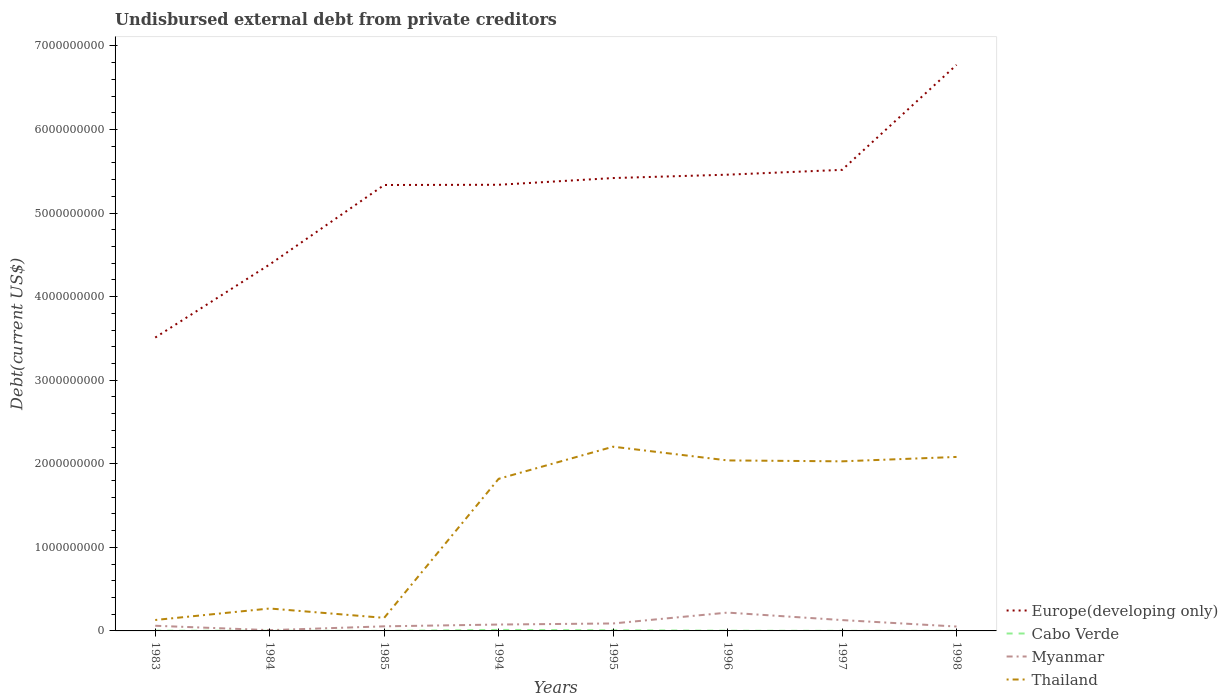Across all years, what is the maximum total debt in Cabo Verde?
Make the answer very short. 5.91e+05. In which year was the total debt in Europe(developing only) maximum?
Your answer should be very brief. 1983. What is the total total debt in Thailand in the graph?
Offer a very short reply. -1.55e+09. What is the difference between the highest and the second highest total debt in Thailand?
Provide a short and direct response. 2.07e+09. What is the difference between the highest and the lowest total debt in Thailand?
Keep it short and to the point. 5. Is the total debt in Myanmar strictly greater than the total debt in Cabo Verde over the years?
Provide a short and direct response. No. How many lines are there?
Your answer should be compact. 4. Are the values on the major ticks of Y-axis written in scientific E-notation?
Your answer should be very brief. No. Does the graph contain any zero values?
Provide a short and direct response. No. Does the graph contain grids?
Your response must be concise. No. Where does the legend appear in the graph?
Your answer should be very brief. Bottom right. How are the legend labels stacked?
Offer a terse response. Vertical. What is the title of the graph?
Offer a very short reply. Undisbursed external debt from private creditors. What is the label or title of the Y-axis?
Your response must be concise. Debt(current US$). What is the Debt(current US$) in Europe(developing only) in 1983?
Your response must be concise. 3.51e+09. What is the Debt(current US$) of Cabo Verde in 1983?
Your answer should be very brief. 3.00e+06. What is the Debt(current US$) in Myanmar in 1983?
Offer a very short reply. 6.17e+07. What is the Debt(current US$) of Thailand in 1983?
Your answer should be very brief. 1.31e+08. What is the Debt(current US$) of Europe(developing only) in 1984?
Your answer should be compact. 4.39e+09. What is the Debt(current US$) in Cabo Verde in 1984?
Offer a very short reply. 1.56e+06. What is the Debt(current US$) in Myanmar in 1984?
Provide a succinct answer. 9.16e+06. What is the Debt(current US$) of Thailand in 1984?
Provide a short and direct response. 2.68e+08. What is the Debt(current US$) of Europe(developing only) in 1985?
Provide a succinct answer. 5.34e+09. What is the Debt(current US$) of Cabo Verde in 1985?
Keep it short and to the point. 5.91e+05. What is the Debt(current US$) in Myanmar in 1985?
Your answer should be very brief. 5.49e+07. What is the Debt(current US$) in Thailand in 1985?
Your answer should be very brief. 1.56e+08. What is the Debt(current US$) in Europe(developing only) in 1994?
Provide a succinct answer. 5.34e+09. What is the Debt(current US$) of Cabo Verde in 1994?
Give a very brief answer. 1.20e+07. What is the Debt(current US$) of Myanmar in 1994?
Provide a short and direct response. 7.64e+07. What is the Debt(current US$) of Thailand in 1994?
Offer a terse response. 1.82e+09. What is the Debt(current US$) of Europe(developing only) in 1995?
Your answer should be compact. 5.42e+09. What is the Debt(current US$) in Cabo Verde in 1995?
Provide a short and direct response. 7.76e+06. What is the Debt(current US$) in Myanmar in 1995?
Give a very brief answer. 8.93e+07. What is the Debt(current US$) in Thailand in 1995?
Provide a succinct answer. 2.20e+09. What is the Debt(current US$) of Europe(developing only) in 1996?
Make the answer very short. 5.46e+09. What is the Debt(current US$) of Cabo Verde in 1996?
Your answer should be compact. 2.41e+06. What is the Debt(current US$) in Myanmar in 1996?
Your answer should be very brief. 2.19e+08. What is the Debt(current US$) of Thailand in 1996?
Provide a succinct answer. 2.04e+09. What is the Debt(current US$) in Europe(developing only) in 1997?
Ensure brevity in your answer.  5.52e+09. What is the Debt(current US$) in Cabo Verde in 1997?
Offer a terse response. 9.48e+05. What is the Debt(current US$) in Myanmar in 1997?
Ensure brevity in your answer.  1.30e+08. What is the Debt(current US$) of Thailand in 1997?
Ensure brevity in your answer.  2.03e+09. What is the Debt(current US$) in Europe(developing only) in 1998?
Provide a succinct answer. 6.77e+09. What is the Debt(current US$) in Cabo Verde in 1998?
Your response must be concise. 9.48e+05. What is the Debt(current US$) of Myanmar in 1998?
Provide a short and direct response. 5.25e+07. What is the Debt(current US$) in Thailand in 1998?
Keep it short and to the point. 2.08e+09. Across all years, what is the maximum Debt(current US$) in Europe(developing only)?
Ensure brevity in your answer.  6.77e+09. Across all years, what is the maximum Debt(current US$) of Cabo Verde?
Offer a very short reply. 1.20e+07. Across all years, what is the maximum Debt(current US$) of Myanmar?
Give a very brief answer. 2.19e+08. Across all years, what is the maximum Debt(current US$) in Thailand?
Your response must be concise. 2.20e+09. Across all years, what is the minimum Debt(current US$) of Europe(developing only)?
Your response must be concise. 3.51e+09. Across all years, what is the minimum Debt(current US$) in Cabo Verde?
Offer a terse response. 5.91e+05. Across all years, what is the minimum Debt(current US$) in Myanmar?
Provide a short and direct response. 9.16e+06. Across all years, what is the minimum Debt(current US$) of Thailand?
Provide a short and direct response. 1.31e+08. What is the total Debt(current US$) of Europe(developing only) in the graph?
Give a very brief answer. 4.17e+1. What is the total Debt(current US$) of Cabo Verde in the graph?
Make the answer very short. 2.92e+07. What is the total Debt(current US$) of Myanmar in the graph?
Your response must be concise. 6.93e+08. What is the total Debt(current US$) in Thailand in the graph?
Keep it short and to the point. 1.07e+1. What is the difference between the Debt(current US$) of Europe(developing only) in 1983 and that in 1984?
Offer a terse response. -8.75e+08. What is the difference between the Debt(current US$) in Cabo Verde in 1983 and that in 1984?
Make the answer very short. 1.44e+06. What is the difference between the Debt(current US$) of Myanmar in 1983 and that in 1984?
Your answer should be very brief. 5.25e+07. What is the difference between the Debt(current US$) in Thailand in 1983 and that in 1984?
Your answer should be very brief. -1.38e+08. What is the difference between the Debt(current US$) in Europe(developing only) in 1983 and that in 1985?
Give a very brief answer. -1.83e+09. What is the difference between the Debt(current US$) of Cabo Verde in 1983 and that in 1985?
Your response must be concise. 2.41e+06. What is the difference between the Debt(current US$) in Myanmar in 1983 and that in 1985?
Provide a succinct answer. 6.79e+06. What is the difference between the Debt(current US$) in Thailand in 1983 and that in 1985?
Ensure brevity in your answer.  -2.55e+07. What is the difference between the Debt(current US$) in Europe(developing only) in 1983 and that in 1994?
Provide a short and direct response. -1.83e+09. What is the difference between the Debt(current US$) of Cabo Verde in 1983 and that in 1994?
Give a very brief answer. -9.00e+06. What is the difference between the Debt(current US$) of Myanmar in 1983 and that in 1994?
Your response must be concise. -1.47e+07. What is the difference between the Debt(current US$) in Thailand in 1983 and that in 1994?
Your response must be concise. -1.69e+09. What is the difference between the Debt(current US$) of Europe(developing only) in 1983 and that in 1995?
Give a very brief answer. -1.91e+09. What is the difference between the Debt(current US$) of Cabo Verde in 1983 and that in 1995?
Offer a very short reply. -4.76e+06. What is the difference between the Debt(current US$) in Myanmar in 1983 and that in 1995?
Make the answer very short. -2.76e+07. What is the difference between the Debt(current US$) of Thailand in 1983 and that in 1995?
Make the answer very short. -2.07e+09. What is the difference between the Debt(current US$) in Europe(developing only) in 1983 and that in 1996?
Keep it short and to the point. -1.95e+09. What is the difference between the Debt(current US$) of Cabo Verde in 1983 and that in 1996?
Give a very brief answer. 5.92e+05. What is the difference between the Debt(current US$) of Myanmar in 1983 and that in 1996?
Your answer should be very brief. -1.58e+08. What is the difference between the Debt(current US$) in Thailand in 1983 and that in 1996?
Your answer should be compact. -1.91e+09. What is the difference between the Debt(current US$) of Europe(developing only) in 1983 and that in 1997?
Keep it short and to the point. -2.01e+09. What is the difference between the Debt(current US$) of Cabo Verde in 1983 and that in 1997?
Make the answer very short. 2.05e+06. What is the difference between the Debt(current US$) in Myanmar in 1983 and that in 1997?
Ensure brevity in your answer.  -6.81e+07. What is the difference between the Debt(current US$) in Thailand in 1983 and that in 1997?
Ensure brevity in your answer.  -1.90e+09. What is the difference between the Debt(current US$) of Europe(developing only) in 1983 and that in 1998?
Make the answer very short. -3.26e+09. What is the difference between the Debt(current US$) in Cabo Verde in 1983 and that in 1998?
Provide a short and direct response. 2.05e+06. What is the difference between the Debt(current US$) in Myanmar in 1983 and that in 1998?
Your response must be concise. 9.18e+06. What is the difference between the Debt(current US$) in Thailand in 1983 and that in 1998?
Your answer should be very brief. -1.95e+09. What is the difference between the Debt(current US$) of Europe(developing only) in 1984 and that in 1985?
Your answer should be very brief. -9.50e+08. What is the difference between the Debt(current US$) in Cabo Verde in 1984 and that in 1985?
Your response must be concise. 9.72e+05. What is the difference between the Debt(current US$) in Myanmar in 1984 and that in 1985?
Your answer should be compact. -4.57e+07. What is the difference between the Debt(current US$) in Thailand in 1984 and that in 1985?
Ensure brevity in your answer.  1.12e+08. What is the difference between the Debt(current US$) in Europe(developing only) in 1984 and that in 1994?
Your answer should be compact. -9.53e+08. What is the difference between the Debt(current US$) in Cabo Verde in 1984 and that in 1994?
Your answer should be compact. -1.04e+07. What is the difference between the Debt(current US$) in Myanmar in 1984 and that in 1994?
Make the answer very short. -6.72e+07. What is the difference between the Debt(current US$) in Thailand in 1984 and that in 1994?
Your response must be concise. -1.55e+09. What is the difference between the Debt(current US$) of Europe(developing only) in 1984 and that in 1995?
Offer a very short reply. -1.03e+09. What is the difference between the Debt(current US$) in Cabo Verde in 1984 and that in 1995?
Ensure brevity in your answer.  -6.19e+06. What is the difference between the Debt(current US$) in Myanmar in 1984 and that in 1995?
Make the answer very short. -8.01e+07. What is the difference between the Debt(current US$) of Thailand in 1984 and that in 1995?
Your answer should be very brief. -1.94e+09. What is the difference between the Debt(current US$) of Europe(developing only) in 1984 and that in 1996?
Make the answer very short. -1.07e+09. What is the difference between the Debt(current US$) of Cabo Verde in 1984 and that in 1996?
Your answer should be compact. -8.45e+05. What is the difference between the Debt(current US$) of Myanmar in 1984 and that in 1996?
Provide a short and direct response. -2.10e+08. What is the difference between the Debt(current US$) of Thailand in 1984 and that in 1996?
Give a very brief answer. -1.77e+09. What is the difference between the Debt(current US$) in Europe(developing only) in 1984 and that in 1997?
Keep it short and to the point. -1.13e+09. What is the difference between the Debt(current US$) of Cabo Verde in 1984 and that in 1997?
Ensure brevity in your answer.  6.15e+05. What is the difference between the Debt(current US$) in Myanmar in 1984 and that in 1997?
Make the answer very short. -1.21e+08. What is the difference between the Debt(current US$) of Thailand in 1984 and that in 1997?
Make the answer very short. -1.76e+09. What is the difference between the Debt(current US$) in Europe(developing only) in 1984 and that in 1998?
Provide a succinct answer. -2.39e+09. What is the difference between the Debt(current US$) in Cabo Verde in 1984 and that in 1998?
Ensure brevity in your answer.  6.15e+05. What is the difference between the Debt(current US$) in Myanmar in 1984 and that in 1998?
Keep it short and to the point. -4.33e+07. What is the difference between the Debt(current US$) in Thailand in 1984 and that in 1998?
Make the answer very short. -1.81e+09. What is the difference between the Debt(current US$) of Europe(developing only) in 1985 and that in 1994?
Your answer should be very brief. -2.66e+06. What is the difference between the Debt(current US$) of Cabo Verde in 1985 and that in 1994?
Provide a short and direct response. -1.14e+07. What is the difference between the Debt(current US$) of Myanmar in 1985 and that in 1994?
Keep it short and to the point. -2.15e+07. What is the difference between the Debt(current US$) in Thailand in 1985 and that in 1994?
Your answer should be very brief. -1.66e+09. What is the difference between the Debt(current US$) of Europe(developing only) in 1985 and that in 1995?
Your answer should be very brief. -8.31e+07. What is the difference between the Debt(current US$) in Cabo Verde in 1985 and that in 1995?
Offer a terse response. -7.16e+06. What is the difference between the Debt(current US$) in Myanmar in 1985 and that in 1995?
Give a very brief answer. -3.44e+07. What is the difference between the Debt(current US$) in Thailand in 1985 and that in 1995?
Your answer should be very brief. -2.05e+09. What is the difference between the Debt(current US$) in Europe(developing only) in 1985 and that in 1996?
Provide a short and direct response. -1.23e+08. What is the difference between the Debt(current US$) in Cabo Verde in 1985 and that in 1996?
Provide a short and direct response. -1.82e+06. What is the difference between the Debt(current US$) of Myanmar in 1985 and that in 1996?
Provide a succinct answer. -1.64e+08. What is the difference between the Debt(current US$) of Thailand in 1985 and that in 1996?
Your answer should be compact. -1.88e+09. What is the difference between the Debt(current US$) in Europe(developing only) in 1985 and that in 1997?
Your answer should be very brief. -1.81e+08. What is the difference between the Debt(current US$) in Cabo Verde in 1985 and that in 1997?
Your answer should be very brief. -3.57e+05. What is the difference between the Debt(current US$) in Myanmar in 1985 and that in 1997?
Provide a succinct answer. -7.49e+07. What is the difference between the Debt(current US$) of Thailand in 1985 and that in 1997?
Give a very brief answer. -1.87e+09. What is the difference between the Debt(current US$) of Europe(developing only) in 1985 and that in 1998?
Ensure brevity in your answer.  -1.44e+09. What is the difference between the Debt(current US$) in Cabo Verde in 1985 and that in 1998?
Make the answer very short. -3.57e+05. What is the difference between the Debt(current US$) of Myanmar in 1985 and that in 1998?
Give a very brief answer. 2.39e+06. What is the difference between the Debt(current US$) in Thailand in 1985 and that in 1998?
Offer a very short reply. -1.93e+09. What is the difference between the Debt(current US$) of Europe(developing only) in 1994 and that in 1995?
Make the answer very short. -8.05e+07. What is the difference between the Debt(current US$) in Cabo Verde in 1994 and that in 1995?
Your response must be concise. 4.24e+06. What is the difference between the Debt(current US$) in Myanmar in 1994 and that in 1995?
Offer a very short reply. -1.29e+07. What is the difference between the Debt(current US$) in Thailand in 1994 and that in 1995?
Provide a short and direct response. -3.84e+08. What is the difference between the Debt(current US$) of Europe(developing only) in 1994 and that in 1996?
Ensure brevity in your answer.  -1.21e+08. What is the difference between the Debt(current US$) in Cabo Verde in 1994 and that in 1996?
Provide a short and direct response. 9.59e+06. What is the difference between the Debt(current US$) of Myanmar in 1994 and that in 1996?
Make the answer very short. -1.43e+08. What is the difference between the Debt(current US$) in Thailand in 1994 and that in 1996?
Ensure brevity in your answer.  -2.20e+08. What is the difference between the Debt(current US$) of Europe(developing only) in 1994 and that in 1997?
Give a very brief answer. -1.78e+08. What is the difference between the Debt(current US$) of Cabo Verde in 1994 and that in 1997?
Ensure brevity in your answer.  1.11e+07. What is the difference between the Debt(current US$) of Myanmar in 1994 and that in 1997?
Give a very brief answer. -5.34e+07. What is the difference between the Debt(current US$) in Thailand in 1994 and that in 1997?
Offer a terse response. -2.09e+08. What is the difference between the Debt(current US$) in Europe(developing only) in 1994 and that in 1998?
Keep it short and to the point. -1.43e+09. What is the difference between the Debt(current US$) of Cabo Verde in 1994 and that in 1998?
Your answer should be very brief. 1.11e+07. What is the difference between the Debt(current US$) of Myanmar in 1994 and that in 1998?
Provide a succinct answer. 2.39e+07. What is the difference between the Debt(current US$) in Thailand in 1994 and that in 1998?
Your response must be concise. -2.62e+08. What is the difference between the Debt(current US$) of Europe(developing only) in 1995 and that in 1996?
Your answer should be compact. -4.04e+07. What is the difference between the Debt(current US$) in Cabo Verde in 1995 and that in 1996?
Provide a short and direct response. 5.35e+06. What is the difference between the Debt(current US$) in Myanmar in 1995 and that in 1996?
Your answer should be very brief. -1.30e+08. What is the difference between the Debt(current US$) of Thailand in 1995 and that in 1996?
Ensure brevity in your answer.  1.64e+08. What is the difference between the Debt(current US$) in Europe(developing only) in 1995 and that in 1997?
Give a very brief answer. -9.80e+07. What is the difference between the Debt(current US$) of Cabo Verde in 1995 and that in 1997?
Provide a succinct answer. 6.81e+06. What is the difference between the Debt(current US$) in Myanmar in 1995 and that in 1997?
Offer a very short reply. -4.04e+07. What is the difference between the Debt(current US$) in Thailand in 1995 and that in 1997?
Your answer should be very brief. 1.75e+08. What is the difference between the Debt(current US$) of Europe(developing only) in 1995 and that in 1998?
Your answer should be very brief. -1.35e+09. What is the difference between the Debt(current US$) of Cabo Verde in 1995 and that in 1998?
Give a very brief answer. 6.81e+06. What is the difference between the Debt(current US$) in Myanmar in 1995 and that in 1998?
Your answer should be compact. 3.68e+07. What is the difference between the Debt(current US$) in Thailand in 1995 and that in 1998?
Your answer should be compact. 1.23e+08. What is the difference between the Debt(current US$) in Europe(developing only) in 1996 and that in 1997?
Make the answer very short. -5.77e+07. What is the difference between the Debt(current US$) in Cabo Verde in 1996 and that in 1997?
Provide a succinct answer. 1.46e+06. What is the difference between the Debt(current US$) in Myanmar in 1996 and that in 1997?
Provide a short and direct response. 8.95e+07. What is the difference between the Debt(current US$) of Thailand in 1996 and that in 1997?
Keep it short and to the point. 1.09e+07. What is the difference between the Debt(current US$) of Europe(developing only) in 1996 and that in 1998?
Provide a short and direct response. -1.31e+09. What is the difference between the Debt(current US$) of Cabo Verde in 1996 and that in 1998?
Make the answer very short. 1.46e+06. What is the difference between the Debt(current US$) in Myanmar in 1996 and that in 1998?
Provide a short and direct response. 1.67e+08. What is the difference between the Debt(current US$) in Thailand in 1996 and that in 1998?
Your answer should be compact. -4.16e+07. What is the difference between the Debt(current US$) in Europe(developing only) in 1997 and that in 1998?
Your response must be concise. -1.26e+09. What is the difference between the Debt(current US$) in Myanmar in 1997 and that in 1998?
Make the answer very short. 7.72e+07. What is the difference between the Debt(current US$) in Thailand in 1997 and that in 1998?
Offer a terse response. -5.25e+07. What is the difference between the Debt(current US$) in Europe(developing only) in 1983 and the Debt(current US$) in Cabo Verde in 1984?
Offer a very short reply. 3.51e+09. What is the difference between the Debt(current US$) in Europe(developing only) in 1983 and the Debt(current US$) in Myanmar in 1984?
Make the answer very short. 3.50e+09. What is the difference between the Debt(current US$) in Europe(developing only) in 1983 and the Debt(current US$) in Thailand in 1984?
Give a very brief answer. 3.24e+09. What is the difference between the Debt(current US$) of Cabo Verde in 1983 and the Debt(current US$) of Myanmar in 1984?
Provide a short and direct response. -6.16e+06. What is the difference between the Debt(current US$) in Cabo Verde in 1983 and the Debt(current US$) in Thailand in 1984?
Give a very brief answer. -2.65e+08. What is the difference between the Debt(current US$) in Myanmar in 1983 and the Debt(current US$) in Thailand in 1984?
Offer a terse response. -2.07e+08. What is the difference between the Debt(current US$) of Europe(developing only) in 1983 and the Debt(current US$) of Cabo Verde in 1985?
Offer a terse response. 3.51e+09. What is the difference between the Debt(current US$) in Europe(developing only) in 1983 and the Debt(current US$) in Myanmar in 1985?
Your answer should be compact. 3.46e+09. What is the difference between the Debt(current US$) in Europe(developing only) in 1983 and the Debt(current US$) in Thailand in 1985?
Your answer should be very brief. 3.35e+09. What is the difference between the Debt(current US$) of Cabo Verde in 1983 and the Debt(current US$) of Myanmar in 1985?
Give a very brief answer. -5.19e+07. What is the difference between the Debt(current US$) of Cabo Verde in 1983 and the Debt(current US$) of Thailand in 1985?
Your answer should be compact. -1.53e+08. What is the difference between the Debt(current US$) of Myanmar in 1983 and the Debt(current US$) of Thailand in 1985?
Ensure brevity in your answer.  -9.46e+07. What is the difference between the Debt(current US$) in Europe(developing only) in 1983 and the Debt(current US$) in Cabo Verde in 1994?
Your answer should be compact. 3.50e+09. What is the difference between the Debt(current US$) in Europe(developing only) in 1983 and the Debt(current US$) in Myanmar in 1994?
Offer a terse response. 3.43e+09. What is the difference between the Debt(current US$) in Europe(developing only) in 1983 and the Debt(current US$) in Thailand in 1994?
Offer a terse response. 1.69e+09. What is the difference between the Debt(current US$) in Cabo Verde in 1983 and the Debt(current US$) in Myanmar in 1994?
Offer a terse response. -7.34e+07. What is the difference between the Debt(current US$) in Cabo Verde in 1983 and the Debt(current US$) in Thailand in 1994?
Ensure brevity in your answer.  -1.82e+09. What is the difference between the Debt(current US$) in Myanmar in 1983 and the Debt(current US$) in Thailand in 1994?
Your answer should be compact. -1.76e+09. What is the difference between the Debt(current US$) in Europe(developing only) in 1983 and the Debt(current US$) in Cabo Verde in 1995?
Provide a short and direct response. 3.50e+09. What is the difference between the Debt(current US$) of Europe(developing only) in 1983 and the Debt(current US$) of Myanmar in 1995?
Your answer should be compact. 3.42e+09. What is the difference between the Debt(current US$) of Europe(developing only) in 1983 and the Debt(current US$) of Thailand in 1995?
Your response must be concise. 1.31e+09. What is the difference between the Debt(current US$) in Cabo Verde in 1983 and the Debt(current US$) in Myanmar in 1995?
Keep it short and to the point. -8.63e+07. What is the difference between the Debt(current US$) in Cabo Verde in 1983 and the Debt(current US$) in Thailand in 1995?
Provide a succinct answer. -2.20e+09. What is the difference between the Debt(current US$) in Myanmar in 1983 and the Debt(current US$) in Thailand in 1995?
Offer a very short reply. -2.14e+09. What is the difference between the Debt(current US$) of Europe(developing only) in 1983 and the Debt(current US$) of Cabo Verde in 1996?
Give a very brief answer. 3.51e+09. What is the difference between the Debt(current US$) in Europe(developing only) in 1983 and the Debt(current US$) in Myanmar in 1996?
Give a very brief answer. 3.29e+09. What is the difference between the Debt(current US$) in Europe(developing only) in 1983 and the Debt(current US$) in Thailand in 1996?
Offer a very short reply. 1.47e+09. What is the difference between the Debt(current US$) of Cabo Verde in 1983 and the Debt(current US$) of Myanmar in 1996?
Provide a short and direct response. -2.16e+08. What is the difference between the Debt(current US$) in Cabo Verde in 1983 and the Debt(current US$) in Thailand in 1996?
Give a very brief answer. -2.04e+09. What is the difference between the Debt(current US$) of Myanmar in 1983 and the Debt(current US$) of Thailand in 1996?
Provide a short and direct response. -1.98e+09. What is the difference between the Debt(current US$) in Europe(developing only) in 1983 and the Debt(current US$) in Cabo Verde in 1997?
Make the answer very short. 3.51e+09. What is the difference between the Debt(current US$) in Europe(developing only) in 1983 and the Debt(current US$) in Myanmar in 1997?
Your response must be concise. 3.38e+09. What is the difference between the Debt(current US$) of Europe(developing only) in 1983 and the Debt(current US$) of Thailand in 1997?
Keep it short and to the point. 1.48e+09. What is the difference between the Debt(current US$) in Cabo Verde in 1983 and the Debt(current US$) in Myanmar in 1997?
Your response must be concise. -1.27e+08. What is the difference between the Debt(current US$) of Cabo Verde in 1983 and the Debt(current US$) of Thailand in 1997?
Your response must be concise. -2.03e+09. What is the difference between the Debt(current US$) of Myanmar in 1983 and the Debt(current US$) of Thailand in 1997?
Provide a succinct answer. -1.97e+09. What is the difference between the Debt(current US$) of Europe(developing only) in 1983 and the Debt(current US$) of Cabo Verde in 1998?
Give a very brief answer. 3.51e+09. What is the difference between the Debt(current US$) of Europe(developing only) in 1983 and the Debt(current US$) of Myanmar in 1998?
Provide a succinct answer. 3.46e+09. What is the difference between the Debt(current US$) of Europe(developing only) in 1983 and the Debt(current US$) of Thailand in 1998?
Provide a succinct answer. 1.43e+09. What is the difference between the Debt(current US$) of Cabo Verde in 1983 and the Debt(current US$) of Myanmar in 1998?
Your response must be concise. -4.95e+07. What is the difference between the Debt(current US$) in Cabo Verde in 1983 and the Debt(current US$) in Thailand in 1998?
Offer a very short reply. -2.08e+09. What is the difference between the Debt(current US$) of Myanmar in 1983 and the Debt(current US$) of Thailand in 1998?
Your response must be concise. -2.02e+09. What is the difference between the Debt(current US$) of Europe(developing only) in 1984 and the Debt(current US$) of Cabo Verde in 1985?
Provide a succinct answer. 4.38e+09. What is the difference between the Debt(current US$) in Europe(developing only) in 1984 and the Debt(current US$) in Myanmar in 1985?
Provide a succinct answer. 4.33e+09. What is the difference between the Debt(current US$) of Europe(developing only) in 1984 and the Debt(current US$) of Thailand in 1985?
Offer a terse response. 4.23e+09. What is the difference between the Debt(current US$) of Cabo Verde in 1984 and the Debt(current US$) of Myanmar in 1985?
Provide a short and direct response. -5.33e+07. What is the difference between the Debt(current US$) of Cabo Verde in 1984 and the Debt(current US$) of Thailand in 1985?
Provide a succinct answer. -1.55e+08. What is the difference between the Debt(current US$) in Myanmar in 1984 and the Debt(current US$) in Thailand in 1985?
Offer a terse response. -1.47e+08. What is the difference between the Debt(current US$) of Europe(developing only) in 1984 and the Debt(current US$) of Cabo Verde in 1994?
Offer a terse response. 4.37e+09. What is the difference between the Debt(current US$) of Europe(developing only) in 1984 and the Debt(current US$) of Myanmar in 1994?
Give a very brief answer. 4.31e+09. What is the difference between the Debt(current US$) in Europe(developing only) in 1984 and the Debt(current US$) in Thailand in 1994?
Keep it short and to the point. 2.57e+09. What is the difference between the Debt(current US$) of Cabo Verde in 1984 and the Debt(current US$) of Myanmar in 1994?
Give a very brief answer. -7.48e+07. What is the difference between the Debt(current US$) in Cabo Verde in 1984 and the Debt(current US$) in Thailand in 1994?
Make the answer very short. -1.82e+09. What is the difference between the Debt(current US$) of Myanmar in 1984 and the Debt(current US$) of Thailand in 1994?
Your answer should be very brief. -1.81e+09. What is the difference between the Debt(current US$) in Europe(developing only) in 1984 and the Debt(current US$) in Cabo Verde in 1995?
Your answer should be compact. 4.38e+09. What is the difference between the Debt(current US$) of Europe(developing only) in 1984 and the Debt(current US$) of Myanmar in 1995?
Offer a terse response. 4.30e+09. What is the difference between the Debt(current US$) in Europe(developing only) in 1984 and the Debt(current US$) in Thailand in 1995?
Ensure brevity in your answer.  2.18e+09. What is the difference between the Debt(current US$) of Cabo Verde in 1984 and the Debt(current US$) of Myanmar in 1995?
Provide a short and direct response. -8.77e+07. What is the difference between the Debt(current US$) in Cabo Verde in 1984 and the Debt(current US$) in Thailand in 1995?
Provide a succinct answer. -2.20e+09. What is the difference between the Debt(current US$) of Myanmar in 1984 and the Debt(current US$) of Thailand in 1995?
Your answer should be very brief. -2.20e+09. What is the difference between the Debt(current US$) in Europe(developing only) in 1984 and the Debt(current US$) in Cabo Verde in 1996?
Your answer should be very brief. 4.38e+09. What is the difference between the Debt(current US$) in Europe(developing only) in 1984 and the Debt(current US$) in Myanmar in 1996?
Offer a terse response. 4.17e+09. What is the difference between the Debt(current US$) in Europe(developing only) in 1984 and the Debt(current US$) in Thailand in 1996?
Your answer should be compact. 2.35e+09. What is the difference between the Debt(current US$) in Cabo Verde in 1984 and the Debt(current US$) in Myanmar in 1996?
Offer a terse response. -2.18e+08. What is the difference between the Debt(current US$) in Cabo Verde in 1984 and the Debt(current US$) in Thailand in 1996?
Give a very brief answer. -2.04e+09. What is the difference between the Debt(current US$) of Myanmar in 1984 and the Debt(current US$) of Thailand in 1996?
Make the answer very short. -2.03e+09. What is the difference between the Debt(current US$) in Europe(developing only) in 1984 and the Debt(current US$) in Cabo Verde in 1997?
Keep it short and to the point. 4.38e+09. What is the difference between the Debt(current US$) in Europe(developing only) in 1984 and the Debt(current US$) in Myanmar in 1997?
Keep it short and to the point. 4.26e+09. What is the difference between the Debt(current US$) of Europe(developing only) in 1984 and the Debt(current US$) of Thailand in 1997?
Your response must be concise. 2.36e+09. What is the difference between the Debt(current US$) in Cabo Verde in 1984 and the Debt(current US$) in Myanmar in 1997?
Offer a very short reply. -1.28e+08. What is the difference between the Debt(current US$) in Cabo Verde in 1984 and the Debt(current US$) in Thailand in 1997?
Ensure brevity in your answer.  -2.03e+09. What is the difference between the Debt(current US$) in Myanmar in 1984 and the Debt(current US$) in Thailand in 1997?
Your response must be concise. -2.02e+09. What is the difference between the Debt(current US$) of Europe(developing only) in 1984 and the Debt(current US$) of Cabo Verde in 1998?
Offer a terse response. 4.38e+09. What is the difference between the Debt(current US$) in Europe(developing only) in 1984 and the Debt(current US$) in Myanmar in 1998?
Provide a short and direct response. 4.33e+09. What is the difference between the Debt(current US$) of Europe(developing only) in 1984 and the Debt(current US$) of Thailand in 1998?
Provide a succinct answer. 2.30e+09. What is the difference between the Debt(current US$) of Cabo Verde in 1984 and the Debt(current US$) of Myanmar in 1998?
Offer a terse response. -5.09e+07. What is the difference between the Debt(current US$) of Cabo Verde in 1984 and the Debt(current US$) of Thailand in 1998?
Your answer should be very brief. -2.08e+09. What is the difference between the Debt(current US$) in Myanmar in 1984 and the Debt(current US$) in Thailand in 1998?
Offer a very short reply. -2.07e+09. What is the difference between the Debt(current US$) in Europe(developing only) in 1985 and the Debt(current US$) in Cabo Verde in 1994?
Provide a short and direct response. 5.32e+09. What is the difference between the Debt(current US$) in Europe(developing only) in 1985 and the Debt(current US$) in Myanmar in 1994?
Ensure brevity in your answer.  5.26e+09. What is the difference between the Debt(current US$) of Europe(developing only) in 1985 and the Debt(current US$) of Thailand in 1994?
Your response must be concise. 3.52e+09. What is the difference between the Debt(current US$) of Cabo Verde in 1985 and the Debt(current US$) of Myanmar in 1994?
Your answer should be very brief. -7.58e+07. What is the difference between the Debt(current US$) in Cabo Verde in 1985 and the Debt(current US$) in Thailand in 1994?
Provide a succinct answer. -1.82e+09. What is the difference between the Debt(current US$) of Myanmar in 1985 and the Debt(current US$) of Thailand in 1994?
Give a very brief answer. -1.77e+09. What is the difference between the Debt(current US$) in Europe(developing only) in 1985 and the Debt(current US$) in Cabo Verde in 1995?
Ensure brevity in your answer.  5.33e+09. What is the difference between the Debt(current US$) in Europe(developing only) in 1985 and the Debt(current US$) in Myanmar in 1995?
Your response must be concise. 5.25e+09. What is the difference between the Debt(current US$) in Europe(developing only) in 1985 and the Debt(current US$) in Thailand in 1995?
Your response must be concise. 3.13e+09. What is the difference between the Debt(current US$) in Cabo Verde in 1985 and the Debt(current US$) in Myanmar in 1995?
Keep it short and to the point. -8.87e+07. What is the difference between the Debt(current US$) in Cabo Verde in 1985 and the Debt(current US$) in Thailand in 1995?
Keep it short and to the point. -2.20e+09. What is the difference between the Debt(current US$) of Myanmar in 1985 and the Debt(current US$) of Thailand in 1995?
Give a very brief answer. -2.15e+09. What is the difference between the Debt(current US$) in Europe(developing only) in 1985 and the Debt(current US$) in Cabo Verde in 1996?
Your answer should be very brief. 5.33e+09. What is the difference between the Debt(current US$) in Europe(developing only) in 1985 and the Debt(current US$) in Myanmar in 1996?
Keep it short and to the point. 5.12e+09. What is the difference between the Debt(current US$) in Europe(developing only) in 1985 and the Debt(current US$) in Thailand in 1996?
Keep it short and to the point. 3.30e+09. What is the difference between the Debt(current US$) of Cabo Verde in 1985 and the Debt(current US$) of Myanmar in 1996?
Offer a terse response. -2.19e+08. What is the difference between the Debt(current US$) of Cabo Verde in 1985 and the Debt(current US$) of Thailand in 1996?
Your answer should be very brief. -2.04e+09. What is the difference between the Debt(current US$) of Myanmar in 1985 and the Debt(current US$) of Thailand in 1996?
Keep it short and to the point. -1.99e+09. What is the difference between the Debt(current US$) of Europe(developing only) in 1985 and the Debt(current US$) of Cabo Verde in 1997?
Make the answer very short. 5.33e+09. What is the difference between the Debt(current US$) of Europe(developing only) in 1985 and the Debt(current US$) of Myanmar in 1997?
Provide a succinct answer. 5.21e+09. What is the difference between the Debt(current US$) in Europe(developing only) in 1985 and the Debt(current US$) in Thailand in 1997?
Keep it short and to the point. 3.31e+09. What is the difference between the Debt(current US$) in Cabo Verde in 1985 and the Debt(current US$) in Myanmar in 1997?
Provide a short and direct response. -1.29e+08. What is the difference between the Debt(current US$) in Cabo Verde in 1985 and the Debt(current US$) in Thailand in 1997?
Provide a succinct answer. -2.03e+09. What is the difference between the Debt(current US$) of Myanmar in 1985 and the Debt(current US$) of Thailand in 1997?
Your response must be concise. -1.97e+09. What is the difference between the Debt(current US$) in Europe(developing only) in 1985 and the Debt(current US$) in Cabo Verde in 1998?
Provide a succinct answer. 5.33e+09. What is the difference between the Debt(current US$) in Europe(developing only) in 1985 and the Debt(current US$) in Myanmar in 1998?
Give a very brief answer. 5.28e+09. What is the difference between the Debt(current US$) in Europe(developing only) in 1985 and the Debt(current US$) in Thailand in 1998?
Keep it short and to the point. 3.25e+09. What is the difference between the Debt(current US$) of Cabo Verde in 1985 and the Debt(current US$) of Myanmar in 1998?
Your response must be concise. -5.19e+07. What is the difference between the Debt(current US$) of Cabo Verde in 1985 and the Debt(current US$) of Thailand in 1998?
Your answer should be very brief. -2.08e+09. What is the difference between the Debt(current US$) in Myanmar in 1985 and the Debt(current US$) in Thailand in 1998?
Ensure brevity in your answer.  -2.03e+09. What is the difference between the Debt(current US$) in Europe(developing only) in 1994 and the Debt(current US$) in Cabo Verde in 1995?
Ensure brevity in your answer.  5.33e+09. What is the difference between the Debt(current US$) of Europe(developing only) in 1994 and the Debt(current US$) of Myanmar in 1995?
Provide a short and direct response. 5.25e+09. What is the difference between the Debt(current US$) of Europe(developing only) in 1994 and the Debt(current US$) of Thailand in 1995?
Give a very brief answer. 3.13e+09. What is the difference between the Debt(current US$) of Cabo Verde in 1994 and the Debt(current US$) of Myanmar in 1995?
Keep it short and to the point. -7.73e+07. What is the difference between the Debt(current US$) in Cabo Verde in 1994 and the Debt(current US$) in Thailand in 1995?
Give a very brief answer. -2.19e+09. What is the difference between the Debt(current US$) of Myanmar in 1994 and the Debt(current US$) of Thailand in 1995?
Keep it short and to the point. -2.13e+09. What is the difference between the Debt(current US$) in Europe(developing only) in 1994 and the Debt(current US$) in Cabo Verde in 1996?
Offer a terse response. 5.34e+09. What is the difference between the Debt(current US$) of Europe(developing only) in 1994 and the Debt(current US$) of Myanmar in 1996?
Provide a short and direct response. 5.12e+09. What is the difference between the Debt(current US$) in Europe(developing only) in 1994 and the Debt(current US$) in Thailand in 1996?
Provide a succinct answer. 3.30e+09. What is the difference between the Debt(current US$) in Cabo Verde in 1994 and the Debt(current US$) in Myanmar in 1996?
Your answer should be very brief. -2.07e+08. What is the difference between the Debt(current US$) in Cabo Verde in 1994 and the Debt(current US$) in Thailand in 1996?
Ensure brevity in your answer.  -2.03e+09. What is the difference between the Debt(current US$) in Myanmar in 1994 and the Debt(current US$) in Thailand in 1996?
Ensure brevity in your answer.  -1.96e+09. What is the difference between the Debt(current US$) in Europe(developing only) in 1994 and the Debt(current US$) in Cabo Verde in 1997?
Offer a very short reply. 5.34e+09. What is the difference between the Debt(current US$) in Europe(developing only) in 1994 and the Debt(current US$) in Myanmar in 1997?
Give a very brief answer. 5.21e+09. What is the difference between the Debt(current US$) of Europe(developing only) in 1994 and the Debt(current US$) of Thailand in 1997?
Your answer should be very brief. 3.31e+09. What is the difference between the Debt(current US$) of Cabo Verde in 1994 and the Debt(current US$) of Myanmar in 1997?
Offer a very short reply. -1.18e+08. What is the difference between the Debt(current US$) of Cabo Verde in 1994 and the Debt(current US$) of Thailand in 1997?
Keep it short and to the point. -2.02e+09. What is the difference between the Debt(current US$) of Myanmar in 1994 and the Debt(current US$) of Thailand in 1997?
Offer a terse response. -1.95e+09. What is the difference between the Debt(current US$) in Europe(developing only) in 1994 and the Debt(current US$) in Cabo Verde in 1998?
Offer a terse response. 5.34e+09. What is the difference between the Debt(current US$) of Europe(developing only) in 1994 and the Debt(current US$) of Myanmar in 1998?
Ensure brevity in your answer.  5.29e+09. What is the difference between the Debt(current US$) of Europe(developing only) in 1994 and the Debt(current US$) of Thailand in 1998?
Your answer should be very brief. 3.26e+09. What is the difference between the Debt(current US$) in Cabo Verde in 1994 and the Debt(current US$) in Myanmar in 1998?
Your answer should be very brief. -4.05e+07. What is the difference between the Debt(current US$) of Cabo Verde in 1994 and the Debt(current US$) of Thailand in 1998?
Your response must be concise. -2.07e+09. What is the difference between the Debt(current US$) of Myanmar in 1994 and the Debt(current US$) of Thailand in 1998?
Offer a very short reply. -2.01e+09. What is the difference between the Debt(current US$) in Europe(developing only) in 1995 and the Debt(current US$) in Cabo Verde in 1996?
Offer a very short reply. 5.42e+09. What is the difference between the Debt(current US$) in Europe(developing only) in 1995 and the Debt(current US$) in Myanmar in 1996?
Offer a terse response. 5.20e+09. What is the difference between the Debt(current US$) in Europe(developing only) in 1995 and the Debt(current US$) in Thailand in 1996?
Make the answer very short. 3.38e+09. What is the difference between the Debt(current US$) of Cabo Verde in 1995 and the Debt(current US$) of Myanmar in 1996?
Make the answer very short. -2.12e+08. What is the difference between the Debt(current US$) in Cabo Verde in 1995 and the Debt(current US$) in Thailand in 1996?
Ensure brevity in your answer.  -2.03e+09. What is the difference between the Debt(current US$) in Myanmar in 1995 and the Debt(current US$) in Thailand in 1996?
Make the answer very short. -1.95e+09. What is the difference between the Debt(current US$) in Europe(developing only) in 1995 and the Debt(current US$) in Cabo Verde in 1997?
Offer a very short reply. 5.42e+09. What is the difference between the Debt(current US$) of Europe(developing only) in 1995 and the Debt(current US$) of Myanmar in 1997?
Your response must be concise. 5.29e+09. What is the difference between the Debt(current US$) of Europe(developing only) in 1995 and the Debt(current US$) of Thailand in 1997?
Ensure brevity in your answer.  3.39e+09. What is the difference between the Debt(current US$) in Cabo Verde in 1995 and the Debt(current US$) in Myanmar in 1997?
Keep it short and to the point. -1.22e+08. What is the difference between the Debt(current US$) of Cabo Verde in 1995 and the Debt(current US$) of Thailand in 1997?
Give a very brief answer. -2.02e+09. What is the difference between the Debt(current US$) in Myanmar in 1995 and the Debt(current US$) in Thailand in 1997?
Your response must be concise. -1.94e+09. What is the difference between the Debt(current US$) in Europe(developing only) in 1995 and the Debt(current US$) in Cabo Verde in 1998?
Offer a terse response. 5.42e+09. What is the difference between the Debt(current US$) of Europe(developing only) in 1995 and the Debt(current US$) of Myanmar in 1998?
Your answer should be compact. 5.37e+09. What is the difference between the Debt(current US$) in Europe(developing only) in 1995 and the Debt(current US$) in Thailand in 1998?
Offer a terse response. 3.34e+09. What is the difference between the Debt(current US$) in Cabo Verde in 1995 and the Debt(current US$) in Myanmar in 1998?
Provide a succinct answer. -4.47e+07. What is the difference between the Debt(current US$) in Cabo Verde in 1995 and the Debt(current US$) in Thailand in 1998?
Provide a short and direct response. -2.07e+09. What is the difference between the Debt(current US$) of Myanmar in 1995 and the Debt(current US$) of Thailand in 1998?
Give a very brief answer. -1.99e+09. What is the difference between the Debt(current US$) in Europe(developing only) in 1996 and the Debt(current US$) in Cabo Verde in 1997?
Your answer should be very brief. 5.46e+09. What is the difference between the Debt(current US$) of Europe(developing only) in 1996 and the Debt(current US$) of Myanmar in 1997?
Your answer should be compact. 5.33e+09. What is the difference between the Debt(current US$) of Europe(developing only) in 1996 and the Debt(current US$) of Thailand in 1997?
Make the answer very short. 3.43e+09. What is the difference between the Debt(current US$) of Cabo Verde in 1996 and the Debt(current US$) of Myanmar in 1997?
Offer a terse response. -1.27e+08. What is the difference between the Debt(current US$) in Cabo Verde in 1996 and the Debt(current US$) in Thailand in 1997?
Ensure brevity in your answer.  -2.03e+09. What is the difference between the Debt(current US$) in Myanmar in 1996 and the Debt(current US$) in Thailand in 1997?
Your answer should be compact. -1.81e+09. What is the difference between the Debt(current US$) in Europe(developing only) in 1996 and the Debt(current US$) in Cabo Verde in 1998?
Make the answer very short. 5.46e+09. What is the difference between the Debt(current US$) of Europe(developing only) in 1996 and the Debt(current US$) of Myanmar in 1998?
Your response must be concise. 5.41e+09. What is the difference between the Debt(current US$) in Europe(developing only) in 1996 and the Debt(current US$) in Thailand in 1998?
Your answer should be compact. 3.38e+09. What is the difference between the Debt(current US$) in Cabo Verde in 1996 and the Debt(current US$) in Myanmar in 1998?
Your answer should be very brief. -5.01e+07. What is the difference between the Debt(current US$) in Cabo Verde in 1996 and the Debt(current US$) in Thailand in 1998?
Ensure brevity in your answer.  -2.08e+09. What is the difference between the Debt(current US$) of Myanmar in 1996 and the Debt(current US$) of Thailand in 1998?
Keep it short and to the point. -1.86e+09. What is the difference between the Debt(current US$) of Europe(developing only) in 1997 and the Debt(current US$) of Cabo Verde in 1998?
Give a very brief answer. 5.52e+09. What is the difference between the Debt(current US$) in Europe(developing only) in 1997 and the Debt(current US$) in Myanmar in 1998?
Make the answer very short. 5.46e+09. What is the difference between the Debt(current US$) of Europe(developing only) in 1997 and the Debt(current US$) of Thailand in 1998?
Your response must be concise. 3.44e+09. What is the difference between the Debt(current US$) in Cabo Verde in 1997 and the Debt(current US$) in Myanmar in 1998?
Provide a succinct answer. -5.15e+07. What is the difference between the Debt(current US$) in Cabo Verde in 1997 and the Debt(current US$) in Thailand in 1998?
Offer a very short reply. -2.08e+09. What is the difference between the Debt(current US$) of Myanmar in 1997 and the Debt(current US$) of Thailand in 1998?
Ensure brevity in your answer.  -1.95e+09. What is the average Debt(current US$) of Europe(developing only) per year?
Provide a short and direct response. 5.22e+09. What is the average Debt(current US$) in Cabo Verde per year?
Your answer should be very brief. 3.65e+06. What is the average Debt(current US$) of Myanmar per year?
Your answer should be very brief. 8.66e+07. What is the average Debt(current US$) of Thailand per year?
Ensure brevity in your answer.  1.34e+09. In the year 1983, what is the difference between the Debt(current US$) of Europe(developing only) and Debt(current US$) of Cabo Verde?
Provide a short and direct response. 3.51e+09. In the year 1983, what is the difference between the Debt(current US$) of Europe(developing only) and Debt(current US$) of Myanmar?
Provide a short and direct response. 3.45e+09. In the year 1983, what is the difference between the Debt(current US$) in Europe(developing only) and Debt(current US$) in Thailand?
Keep it short and to the point. 3.38e+09. In the year 1983, what is the difference between the Debt(current US$) in Cabo Verde and Debt(current US$) in Myanmar?
Your response must be concise. -5.87e+07. In the year 1983, what is the difference between the Debt(current US$) of Cabo Verde and Debt(current US$) of Thailand?
Give a very brief answer. -1.28e+08. In the year 1983, what is the difference between the Debt(current US$) of Myanmar and Debt(current US$) of Thailand?
Offer a terse response. -6.91e+07. In the year 1984, what is the difference between the Debt(current US$) in Europe(developing only) and Debt(current US$) in Cabo Verde?
Offer a terse response. 4.38e+09. In the year 1984, what is the difference between the Debt(current US$) in Europe(developing only) and Debt(current US$) in Myanmar?
Your response must be concise. 4.38e+09. In the year 1984, what is the difference between the Debt(current US$) in Europe(developing only) and Debt(current US$) in Thailand?
Offer a very short reply. 4.12e+09. In the year 1984, what is the difference between the Debt(current US$) of Cabo Verde and Debt(current US$) of Myanmar?
Your response must be concise. -7.60e+06. In the year 1984, what is the difference between the Debt(current US$) of Cabo Verde and Debt(current US$) of Thailand?
Your answer should be compact. -2.67e+08. In the year 1984, what is the difference between the Debt(current US$) of Myanmar and Debt(current US$) of Thailand?
Offer a very short reply. -2.59e+08. In the year 1985, what is the difference between the Debt(current US$) of Europe(developing only) and Debt(current US$) of Cabo Verde?
Provide a succinct answer. 5.34e+09. In the year 1985, what is the difference between the Debt(current US$) of Europe(developing only) and Debt(current US$) of Myanmar?
Keep it short and to the point. 5.28e+09. In the year 1985, what is the difference between the Debt(current US$) in Europe(developing only) and Debt(current US$) in Thailand?
Provide a succinct answer. 5.18e+09. In the year 1985, what is the difference between the Debt(current US$) in Cabo Verde and Debt(current US$) in Myanmar?
Provide a short and direct response. -5.43e+07. In the year 1985, what is the difference between the Debt(current US$) in Cabo Verde and Debt(current US$) in Thailand?
Your answer should be very brief. -1.56e+08. In the year 1985, what is the difference between the Debt(current US$) in Myanmar and Debt(current US$) in Thailand?
Offer a very short reply. -1.01e+08. In the year 1994, what is the difference between the Debt(current US$) in Europe(developing only) and Debt(current US$) in Cabo Verde?
Your response must be concise. 5.33e+09. In the year 1994, what is the difference between the Debt(current US$) of Europe(developing only) and Debt(current US$) of Myanmar?
Provide a short and direct response. 5.26e+09. In the year 1994, what is the difference between the Debt(current US$) in Europe(developing only) and Debt(current US$) in Thailand?
Keep it short and to the point. 3.52e+09. In the year 1994, what is the difference between the Debt(current US$) in Cabo Verde and Debt(current US$) in Myanmar?
Ensure brevity in your answer.  -6.44e+07. In the year 1994, what is the difference between the Debt(current US$) in Cabo Verde and Debt(current US$) in Thailand?
Provide a short and direct response. -1.81e+09. In the year 1994, what is the difference between the Debt(current US$) of Myanmar and Debt(current US$) of Thailand?
Keep it short and to the point. -1.74e+09. In the year 1995, what is the difference between the Debt(current US$) of Europe(developing only) and Debt(current US$) of Cabo Verde?
Offer a very short reply. 5.41e+09. In the year 1995, what is the difference between the Debt(current US$) in Europe(developing only) and Debt(current US$) in Myanmar?
Your answer should be very brief. 5.33e+09. In the year 1995, what is the difference between the Debt(current US$) in Europe(developing only) and Debt(current US$) in Thailand?
Make the answer very short. 3.21e+09. In the year 1995, what is the difference between the Debt(current US$) of Cabo Verde and Debt(current US$) of Myanmar?
Give a very brief answer. -8.15e+07. In the year 1995, what is the difference between the Debt(current US$) of Cabo Verde and Debt(current US$) of Thailand?
Your answer should be compact. -2.20e+09. In the year 1995, what is the difference between the Debt(current US$) of Myanmar and Debt(current US$) of Thailand?
Make the answer very short. -2.11e+09. In the year 1996, what is the difference between the Debt(current US$) in Europe(developing only) and Debt(current US$) in Cabo Verde?
Offer a terse response. 5.46e+09. In the year 1996, what is the difference between the Debt(current US$) in Europe(developing only) and Debt(current US$) in Myanmar?
Give a very brief answer. 5.24e+09. In the year 1996, what is the difference between the Debt(current US$) of Europe(developing only) and Debt(current US$) of Thailand?
Provide a succinct answer. 3.42e+09. In the year 1996, what is the difference between the Debt(current US$) of Cabo Verde and Debt(current US$) of Myanmar?
Offer a very short reply. -2.17e+08. In the year 1996, what is the difference between the Debt(current US$) in Cabo Verde and Debt(current US$) in Thailand?
Your response must be concise. -2.04e+09. In the year 1996, what is the difference between the Debt(current US$) in Myanmar and Debt(current US$) in Thailand?
Provide a succinct answer. -1.82e+09. In the year 1997, what is the difference between the Debt(current US$) in Europe(developing only) and Debt(current US$) in Cabo Verde?
Your answer should be very brief. 5.52e+09. In the year 1997, what is the difference between the Debt(current US$) of Europe(developing only) and Debt(current US$) of Myanmar?
Your answer should be very brief. 5.39e+09. In the year 1997, what is the difference between the Debt(current US$) in Europe(developing only) and Debt(current US$) in Thailand?
Give a very brief answer. 3.49e+09. In the year 1997, what is the difference between the Debt(current US$) of Cabo Verde and Debt(current US$) of Myanmar?
Offer a very short reply. -1.29e+08. In the year 1997, what is the difference between the Debt(current US$) in Cabo Verde and Debt(current US$) in Thailand?
Offer a terse response. -2.03e+09. In the year 1997, what is the difference between the Debt(current US$) of Myanmar and Debt(current US$) of Thailand?
Provide a succinct answer. -1.90e+09. In the year 1998, what is the difference between the Debt(current US$) in Europe(developing only) and Debt(current US$) in Cabo Verde?
Your response must be concise. 6.77e+09. In the year 1998, what is the difference between the Debt(current US$) of Europe(developing only) and Debt(current US$) of Myanmar?
Ensure brevity in your answer.  6.72e+09. In the year 1998, what is the difference between the Debt(current US$) in Europe(developing only) and Debt(current US$) in Thailand?
Keep it short and to the point. 4.69e+09. In the year 1998, what is the difference between the Debt(current US$) of Cabo Verde and Debt(current US$) of Myanmar?
Offer a terse response. -5.15e+07. In the year 1998, what is the difference between the Debt(current US$) of Cabo Verde and Debt(current US$) of Thailand?
Make the answer very short. -2.08e+09. In the year 1998, what is the difference between the Debt(current US$) of Myanmar and Debt(current US$) of Thailand?
Offer a very short reply. -2.03e+09. What is the ratio of the Debt(current US$) in Europe(developing only) in 1983 to that in 1984?
Your answer should be compact. 0.8. What is the ratio of the Debt(current US$) of Cabo Verde in 1983 to that in 1984?
Keep it short and to the point. 1.92. What is the ratio of the Debt(current US$) of Myanmar in 1983 to that in 1984?
Your answer should be very brief. 6.73. What is the ratio of the Debt(current US$) in Thailand in 1983 to that in 1984?
Provide a succinct answer. 0.49. What is the ratio of the Debt(current US$) of Europe(developing only) in 1983 to that in 1985?
Your response must be concise. 0.66. What is the ratio of the Debt(current US$) in Cabo Verde in 1983 to that in 1985?
Provide a succinct answer. 5.08. What is the ratio of the Debt(current US$) of Myanmar in 1983 to that in 1985?
Your answer should be very brief. 1.12. What is the ratio of the Debt(current US$) of Thailand in 1983 to that in 1985?
Provide a succinct answer. 0.84. What is the ratio of the Debt(current US$) of Europe(developing only) in 1983 to that in 1994?
Make the answer very short. 0.66. What is the ratio of the Debt(current US$) of Cabo Verde in 1983 to that in 1994?
Offer a terse response. 0.25. What is the ratio of the Debt(current US$) in Myanmar in 1983 to that in 1994?
Offer a terse response. 0.81. What is the ratio of the Debt(current US$) in Thailand in 1983 to that in 1994?
Offer a terse response. 0.07. What is the ratio of the Debt(current US$) of Europe(developing only) in 1983 to that in 1995?
Your answer should be very brief. 0.65. What is the ratio of the Debt(current US$) in Cabo Verde in 1983 to that in 1995?
Provide a succinct answer. 0.39. What is the ratio of the Debt(current US$) in Myanmar in 1983 to that in 1995?
Your response must be concise. 0.69. What is the ratio of the Debt(current US$) of Thailand in 1983 to that in 1995?
Offer a very short reply. 0.06. What is the ratio of the Debt(current US$) of Europe(developing only) in 1983 to that in 1996?
Give a very brief answer. 0.64. What is the ratio of the Debt(current US$) in Cabo Verde in 1983 to that in 1996?
Offer a very short reply. 1.25. What is the ratio of the Debt(current US$) of Myanmar in 1983 to that in 1996?
Provide a short and direct response. 0.28. What is the ratio of the Debt(current US$) of Thailand in 1983 to that in 1996?
Ensure brevity in your answer.  0.06. What is the ratio of the Debt(current US$) of Europe(developing only) in 1983 to that in 1997?
Your answer should be very brief. 0.64. What is the ratio of the Debt(current US$) in Cabo Verde in 1983 to that in 1997?
Your response must be concise. 3.16. What is the ratio of the Debt(current US$) of Myanmar in 1983 to that in 1997?
Your answer should be compact. 0.48. What is the ratio of the Debt(current US$) in Thailand in 1983 to that in 1997?
Offer a very short reply. 0.06. What is the ratio of the Debt(current US$) in Europe(developing only) in 1983 to that in 1998?
Offer a terse response. 0.52. What is the ratio of the Debt(current US$) in Cabo Verde in 1983 to that in 1998?
Your response must be concise. 3.16. What is the ratio of the Debt(current US$) in Myanmar in 1983 to that in 1998?
Offer a terse response. 1.17. What is the ratio of the Debt(current US$) in Thailand in 1983 to that in 1998?
Your response must be concise. 0.06. What is the ratio of the Debt(current US$) in Europe(developing only) in 1984 to that in 1985?
Your response must be concise. 0.82. What is the ratio of the Debt(current US$) of Cabo Verde in 1984 to that in 1985?
Keep it short and to the point. 2.64. What is the ratio of the Debt(current US$) in Myanmar in 1984 to that in 1985?
Make the answer very short. 0.17. What is the ratio of the Debt(current US$) of Thailand in 1984 to that in 1985?
Offer a terse response. 1.72. What is the ratio of the Debt(current US$) of Europe(developing only) in 1984 to that in 1994?
Make the answer very short. 0.82. What is the ratio of the Debt(current US$) in Cabo Verde in 1984 to that in 1994?
Keep it short and to the point. 0.13. What is the ratio of the Debt(current US$) in Myanmar in 1984 to that in 1994?
Your answer should be compact. 0.12. What is the ratio of the Debt(current US$) in Thailand in 1984 to that in 1994?
Provide a succinct answer. 0.15. What is the ratio of the Debt(current US$) in Europe(developing only) in 1984 to that in 1995?
Provide a succinct answer. 0.81. What is the ratio of the Debt(current US$) of Cabo Verde in 1984 to that in 1995?
Offer a very short reply. 0.2. What is the ratio of the Debt(current US$) in Myanmar in 1984 to that in 1995?
Provide a succinct answer. 0.1. What is the ratio of the Debt(current US$) of Thailand in 1984 to that in 1995?
Make the answer very short. 0.12. What is the ratio of the Debt(current US$) in Europe(developing only) in 1984 to that in 1996?
Your answer should be very brief. 0.8. What is the ratio of the Debt(current US$) in Cabo Verde in 1984 to that in 1996?
Provide a short and direct response. 0.65. What is the ratio of the Debt(current US$) in Myanmar in 1984 to that in 1996?
Give a very brief answer. 0.04. What is the ratio of the Debt(current US$) of Thailand in 1984 to that in 1996?
Make the answer very short. 0.13. What is the ratio of the Debt(current US$) of Europe(developing only) in 1984 to that in 1997?
Keep it short and to the point. 0.79. What is the ratio of the Debt(current US$) of Cabo Verde in 1984 to that in 1997?
Your answer should be very brief. 1.65. What is the ratio of the Debt(current US$) of Myanmar in 1984 to that in 1997?
Make the answer very short. 0.07. What is the ratio of the Debt(current US$) of Thailand in 1984 to that in 1997?
Your response must be concise. 0.13. What is the ratio of the Debt(current US$) of Europe(developing only) in 1984 to that in 1998?
Ensure brevity in your answer.  0.65. What is the ratio of the Debt(current US$) in Cabo Verde in 1984 to that in 1998?
Give a very brief answer. 1.65. What is the ratio of the Debt(current US$) in Myanmar in 1984 to that in 1998?
Offer a very short reply. 0.17. What is the ratio of the Debt(current US$) of Thailand in 1984 to that in 1998?
Provide a short and direct response. 0.13. What is the ratio of the Debt(current US$) of Europe(developing only) in 1985 to that in 1994?
Provide a short and direct response. 1. What is the ratio of the Debt(current US$) of Cabo Verde in 1985 to that in 1994?
Make the answer very short. 0.05. What is the ratio of the Debt(current US$) in Myanmar in 1985 to that in 1994?
Offer a terse response. 0.72. What is the ratio of the Debt(current US$) in Thailand in 1985 to that in 1994?
Offer a terse response. 0.09. What is the ratio of the Debt(current US$) of Europe(developing only) in 1985 to that in 1995?
Give a very brief answer. 0.98. What is the ratio of the Debt(current US$) of Cabo Verde in 1985 to that in 1995?
Offer a very short reply. 0.08. What is the ratio of the Debt(current US$) in Myanmar in 1985 to that in 1995?
Keep it short and to the point. 0.61. What is the ratio of the Debt(current US$) of Thailand in 1985 to that in 1995?
Provide a short and direct response. 0.07. What is the ratio of the Debt(current US$) in Europe(developing only) in 1985 to that in 1996?
Provide a succinct answer. 0.98. What is the ratio of the Debt(current US$) of Cabo Verde in 1985 to that in 1996?
Offer a very short reply. 0.25. What is the ratio of the Debt(current US$) in Myanmar in 1985 to that in 1996?
Offer a terse response. 0.25. What is the ratio of the Debt(current US$) in Thailand in 1985 to that in 1996?
Provide a short and direct response. 0.08. What is the ratio of the Debt(current US$) of Europe(developing only) in 1985 to that in 1997?
Ensure brevity in your answer.  0.97. What is the ratio of the Debt(current US$) of Cabo Verde in 1985 to that in 1997?
Offer a very short reply. 0.62. What is the ratio of the Debt(current US$) of Myanmar in 1985 to that in 1997?
Make the answer very short. 0.42. What is the ratio of the Debt(current US$) of Thailand in 1985 to that in 1997?
Offer a very short reply. 0.08. What is the ratio of the Debt(current US$) of Europe(developing only) in 1985 to that in 1998?
Ensure brevity in your answer.  0.79. What is the ratio of the Debt(current US$) of Cabo Verde in 1985 to that in 1998?
Your answer should be compact. 0.62. What is the ratio of the Debt(current US$) in Myanmar in 1985 to that in 1998?
Give a very brief answer. 1.05. What is the ratio of the Debt(current US$) in Thailand in 1985 to that in 1998?
Make the answer very short. 0.08. What is the ratio of the Debt(current US$) in Europe(developing only) in 1994 to that in 1995?
Offer a terse response. 0.99. What is the ratio of the Debt(current US$) of Cabo Verde in 1994 to that in 1995?
Keep it short and to the point. 1.55. What is the ratio of the Debt(current US$) in Myanmar in 1994 to that in 1995?
Your answer should be compact. 0.86. What is the ratio of the Debt(current US$) of Thailand in 1994 to that in 1995?
Ensure brevity in your answer.  0.83. What is the ratio of the Debt(current US$) of Europe(developing only) in 1994 to that in 1996?
Your answer should be compact. 0.98. What is the ratio of the Debt(current US$) in Cabo Verde in 1994 to that in 1996?
Offer a terse response. 4.98. What is the ratio of the Debt(current US$) in Myanmar in 1994 to that in 1996?
Offer a very short reply. 0.35. What is the ratio of the Debt(current US$) in Thailand in 1994 to that in 1996?
Offer a terse response. 0.89. What is the ratio of the Debt(current US$) in Europe(developing only) in 1994 to that in 1997?
Ensure brevity in your answer.  0.97. What is the ratio of the Debt(current US$) in Cabo Verde in 1994 to that in 1997?
Keep it short and to the point. 12.66. What is the ratio of the Debt(current US$) in Myanmar in 1994 to that in 1997?
Give a very brief answer. 0.59. What is the ratio of the Debt(current US$) of Thailand in 1994 to that in 1997?
Offer a very short reply. 0.9. What is the ratio of the Debt(current US$) in Europe(developing only) in 1994 to that in 1998?
Your response must be concise. 0.79. What is the ratio of the Debt(current US$) of Cabo Verde in 1994 to that in 1998?
Give a very brief answer. 12.66. What is the ratio of the Debt(current US$) of Myanmar in 1994 to that in 1998?
Your response must be concise. 1.46. What is the ratio of the Debt(current US$) in Thailand in 1994 to that in 1998?
Your answer should be compact. 0.87. What is the ratio of the Debt(current US$) of Cabo Verde in 1995 to that in 1996?
Keep it short and to the point. 3.22. What is the ratio of the Debt(current US$) of Myanmar in 1995 to that in 1996?
Offer a very short reply. 0.41. What is the ratio of the Debt(current US$) in Thailand in 1995 to that in 1996?
Your response must be concise. 1.08. What is the ratio of the Debt(current US$) of Europe(developing only) in 1995 to that in 1997?
Your answer should be very brief. 0.98. What is the ratio of the Debt(current US$) in Cabo Verde in 1995 to that in 1997?
Offer a terse response. 8.18. What is the ratio of the Debt(current US$) of Myanmar in 1995 to that in 1997?
Offer a terse response. 0.69. What is the ratio of the Debt(current US$) of Thailand in 1995 to that in 1997?
Keep it short and to the point. 1.09. What is the ratio of the Debt(current US$) in Europe(developing only) in 1995 to that in 1998?
Offer a very short reply. 0.8. What is the ratio of the Debt(current US$) of Cabo Verde in 1995 to that in 1998?
Offer a terse response. 8.18. What is the ratio of the Debt(current US$) in Myanmar in 1995 to that in 1998?
Make the answer very short. 1.7. What is the ratio of the Debt(current US$) in Thailand in 1995 to that in 1998?
Offer a terse response. 1.06. What is the ratio of the Debt(current US$) in Cabo Verde in 1996 to that in 1997?
Keep it short and to the point. 2.54. What is the ratio of the Debt(current US$) in Myanmar in 1996 to that in 1997?
Provide a succinct answer. 1.69. What is the ratio of the Debt(current US$) of Thailand in 1996 to that in 1997?
Keep it short and to the point. 1.01. What is the ratio of the Debt(current US$) in Europe(developing only) in 1996 to that in 1998?
Offer a very short reply. 0.81. What is the ratio of the Debt(current US$) of Cabo Verde in 1996 to that in 1998?
Your answer should be compact. 2.54. What is the ratio of the Debt(current US$) in Myanmar in 1996 to that in 1998?
Offer a terse response. 4.18. What is the ratio of the Debt(current US$) in Thailand in 1996 to that in 1998?
Give a very brief answer. 0.98. What is the ratio of the Debt(current US$) of Europe(developing only) in 1997 to that in 1998?
Your answer should be very brief. 0.81. What is the ratio of the Debt(current US$) in Myanmar in 1997 to that in 1998?
Ensure brevity in your answer.  2.47. What is the ratio of the Debt(current US$) of Thailand in 1997 to that in 1998?
Provide a succinct answer. 0.97. What is the difference between the highest and the second highest Debt(current US$) of Europe(developing only)?
Ensure brevity in your answer.  1.26e+09. What is the difference between the highest and the second highest Debt(current US$) of Cabo Verde?
Offer a terse response. 4.24e+06. What is the difference between the highest and the second highest Debt(current US$) of Myanmar?
Make the answer very short. 8.95e+07. What is the difference between the highest and the second highest Debt(current US$) of Thailand?
Keep it short and to the point. 1.23e+08. What is the difference between the highest and the lowest Debt(current US$) in Europe(developing only)?
Your answer should be very brief. 3.26e+09. What is the difference between the highest and the lowest Debt(current US$) of Cabo Verde?
Make the answer very short. 1.14e+07. What is the difference between the highest and the lowest Debt(current US$) in Myanmar?
Provide a short and direct response. 2.10e+08. What is the difference between the highest and the lowest Debt(current US$) in Thailand?
Make the answer very short. 2.07e+09. 